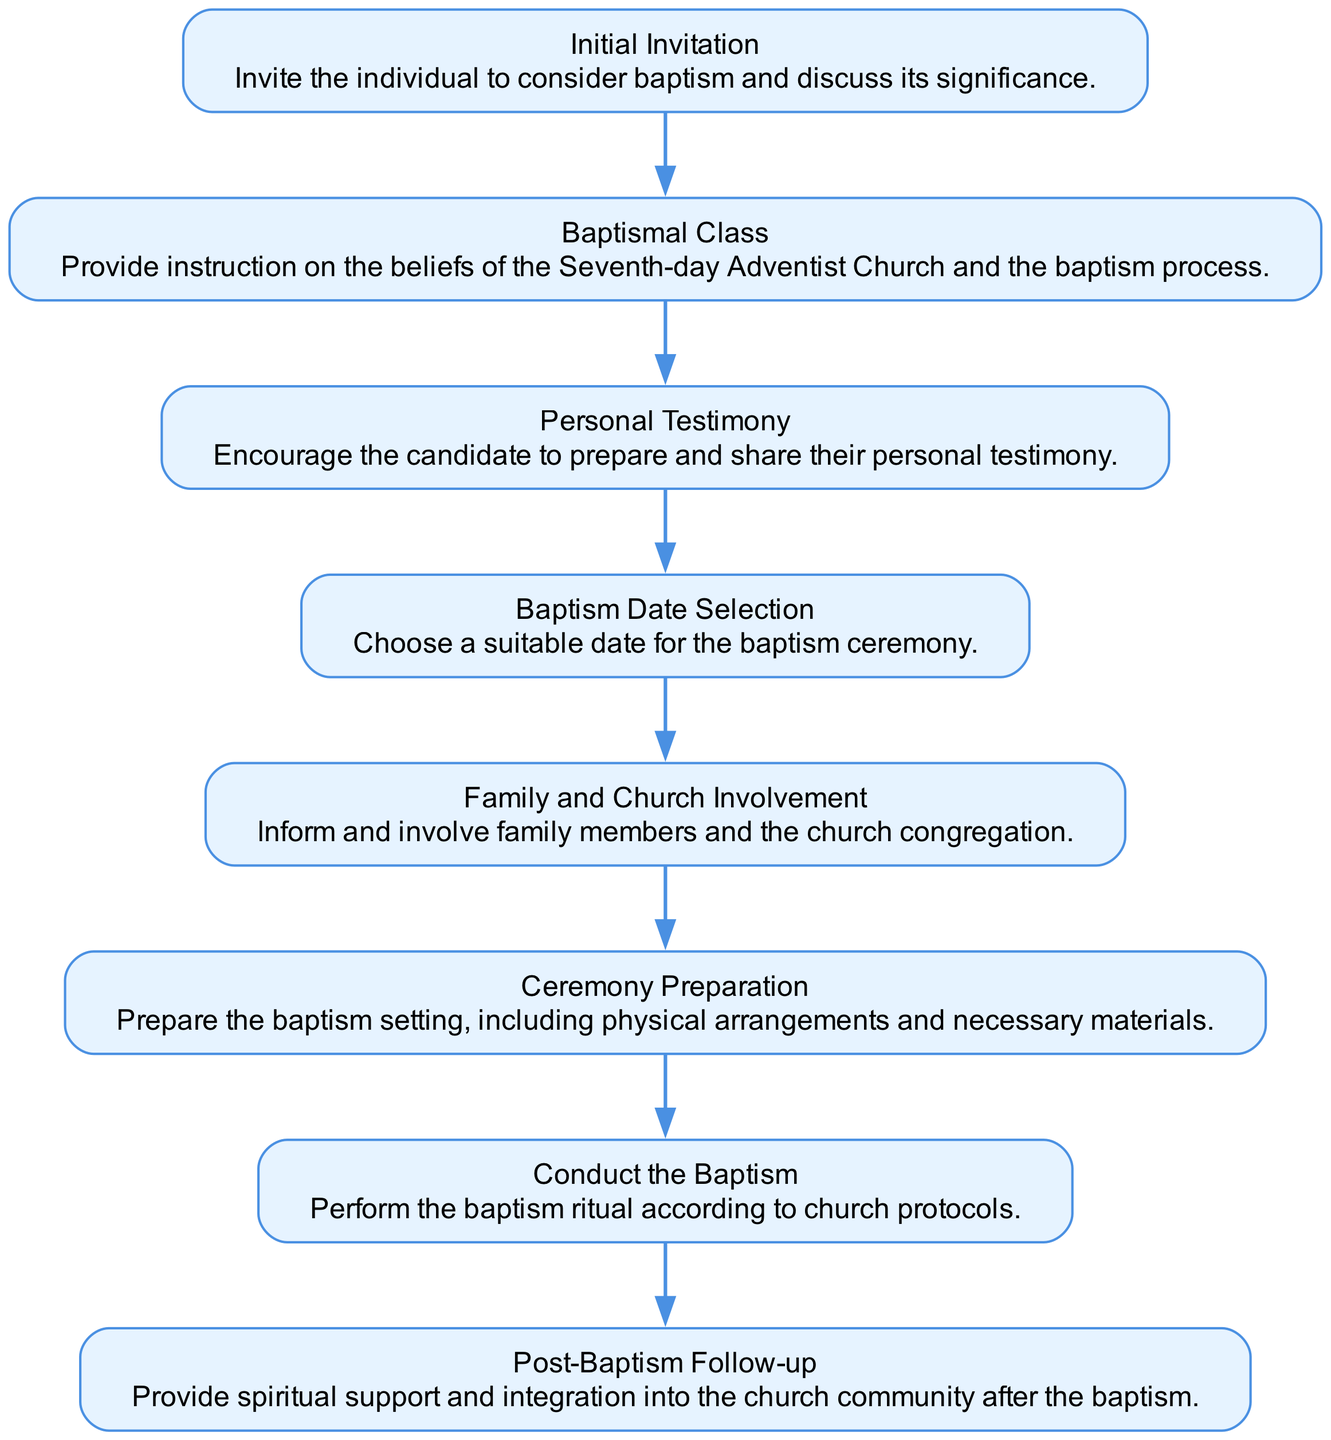What is the first step in the baptism process? The diagram clearly indicates that the first node is "Initial Invitation". This node represents the starting point of the baptism process.
Answer: Initial Invitation How many nodes are there in the flow chart? By counting the elements listed in the diagram, there are a total of eight nodes representing different steps in the baptism process.
Answer: Eight What is the last step after conducting the baptism? The flow chart indicates that after "Conduct the Baptism", the next step is "Post-Baptism Follow-up", highlighting the importance of continued support.
Answer: Post-Baptism Follow-up What follows after the "Baptismal Class"? Following "Baptismal Class", the diagram shows that the next step is "Personal Testimony", implying the candidate's reflection on their faith journey.
Answer: Personal Testimony Which step involves the candidate sharing their experience? The diagram indicates that "Personal Testimony" is the step where the candidate is encouraged to prepare and share their personal experiences related to their faith.
Answer: Personal Testimony How does the involvement of family members and the church occur in the process? The diagram marks "Family and Church Involvement" as a specific step where candidates inform and involve their family and the church community in the baptism process.
Answer: Family and Church Involvement Which step directly leads to the baptism ceremony? The step immediately preceding "Conduct the Baptism" is "Ceremony Preparation", indicating that all arrangements must be completed to facilitate the actual baptism event.
Answer: Ceremony Preparation What is the relationship between "Baptism Date Selection" and "Ceremony Preparation"? "Baptism Date Selection" leads directly to "Ceremony Preparation". This implies that the chosen date impacts how the ceremony is arranged and set up.
Answer: Ceremony Preparation What process is emphasized after the baptism is completed? The diagram highlights that "Post-Baptism Follow-up" is the critical follow-up action to provide support for spiritual growth and community integration post-baptism.
Answer: Post-Baptism Follow-up 